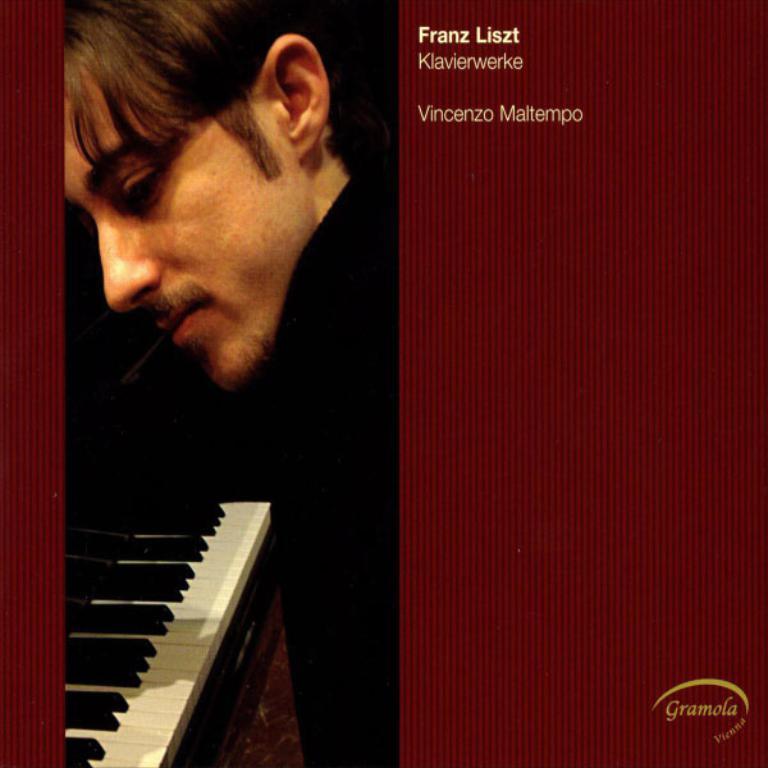How would you summarize this image in a sentence or two? This picture shows a man and a piano and we see text on the top and bottom right corner. 